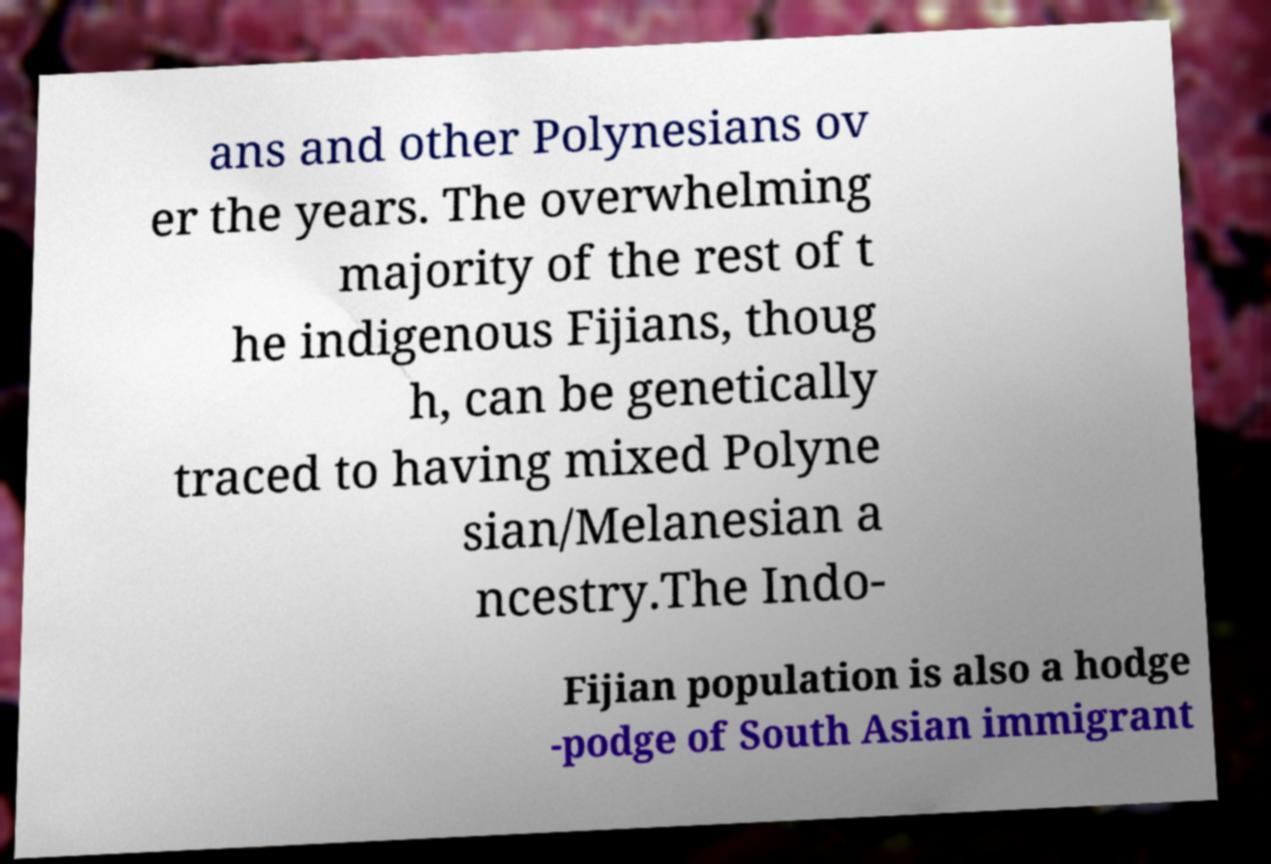There's text embedded in this image that I need extracted. Can you transcribe it verbatim? ans and other Polynesians ov er the years. The overwhelming majority of the rest of t he indigenous Fijians, thoug h, can be genetically traced to having mixed Polyne sian/Melanesian a ncestry.The Indo- Fijian population is also a hodge -podge of South Asian immigrant 